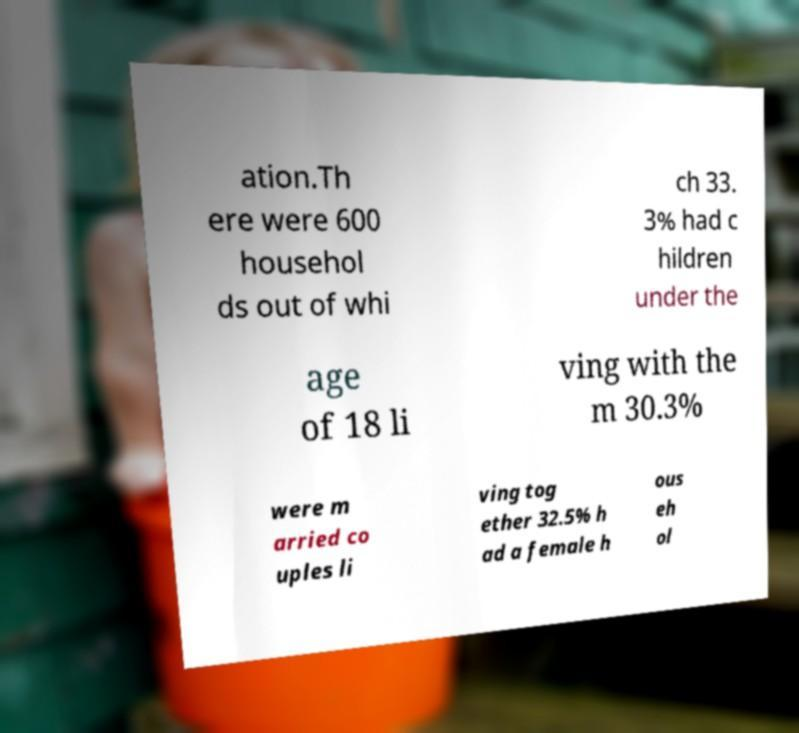Can you accurately transcribe the text from the provided image for me? ation.Th ere were 600 househol ds out of whi ch 33. 3% had c hildren under the age of 18 li ving with the m 30.3% were m arried co uples li ving tog ether 32.5% h ad a female h ous eh ol 